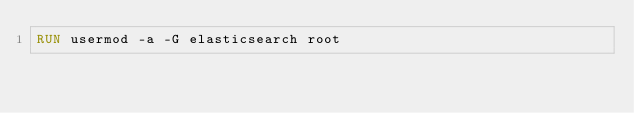Convert code to text. <code><loc_0><loc_0><loc_500><loc_500><_Dockerfile_>RUN usermod -a -G elasticsearch root
</code> 